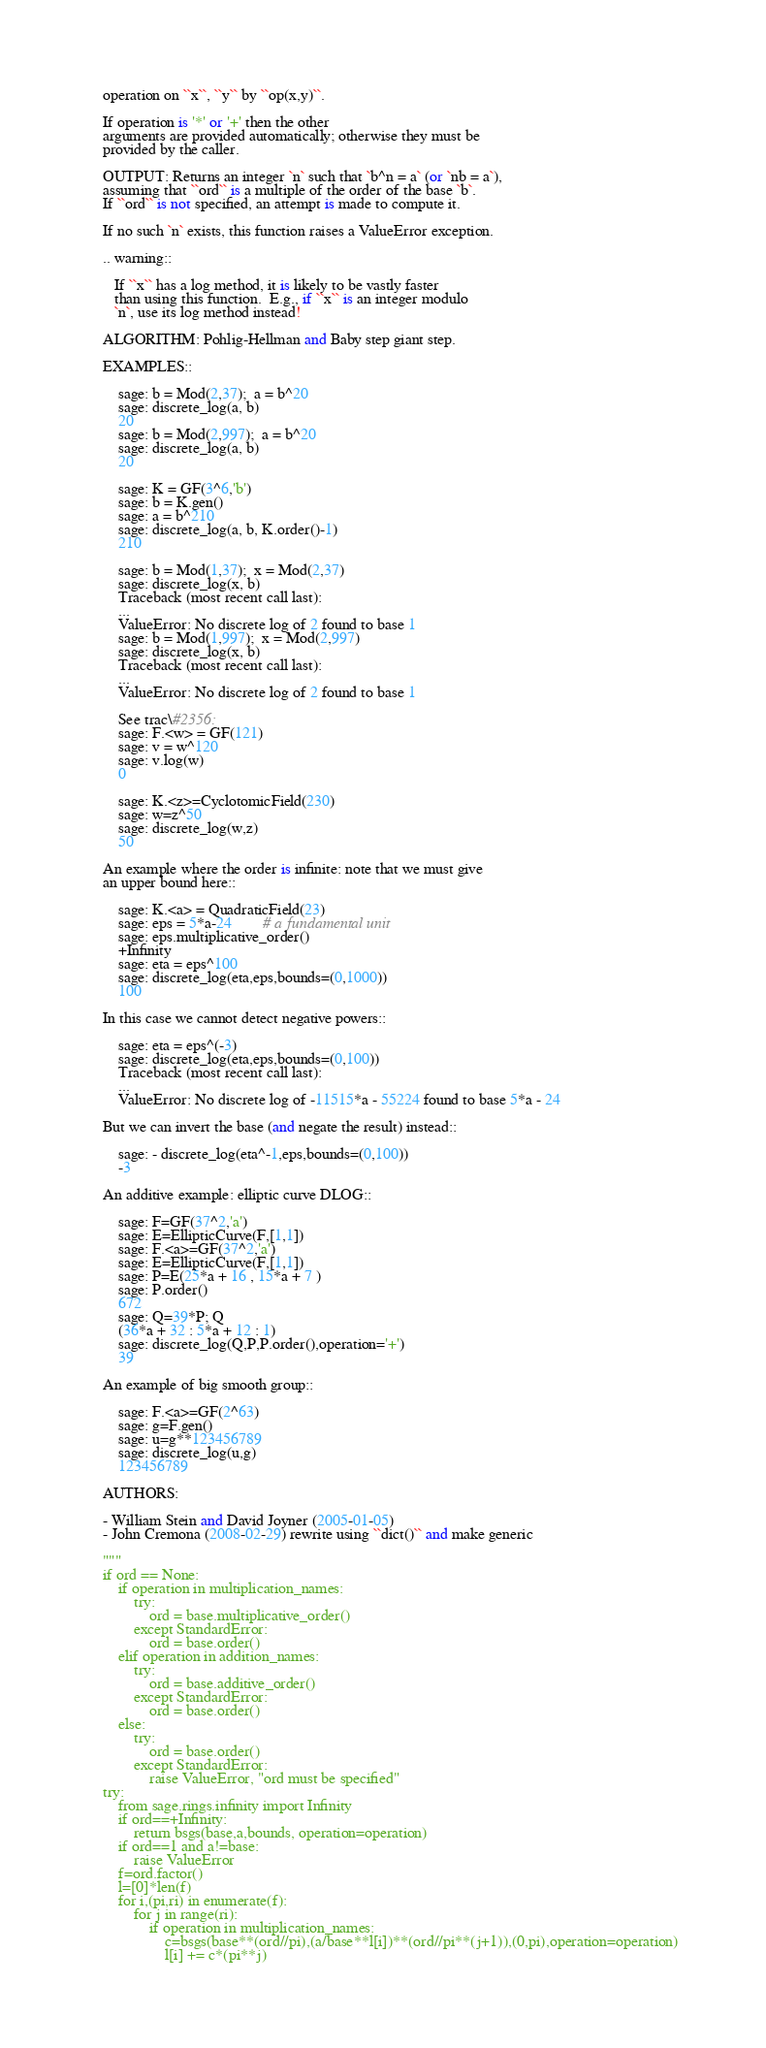Convert code to text. <code><loc_0><loc_0><loc_500><loc_500><_Python_>    operation on ``x``, ``y`` by ``op(x,y)``.

    If operation is '*' or '+' then the other
    arguments are provided automatically; otherwise they must be
    provided by the caller.

    OUTPUT: Returns an integer `n` such that `b^n = a` (or `nb = a`),
    assuming that ``ord`` is a multiple of the order of the base `b`.
    If ``ord`` is not specified, an attempt is made to compute it.

    If no such `n` exists, this function raises a ValueError exception.

    .. warning::

       If ``x`` has a log method, it is likely to be vastly faster
       than using this function.  E.g., if ``x`` is an integer modulo
       `n`, use its log method instead!

    ALGORITHM: Pohlig-Hellman and Baby step giant step.

    EXAMPLES::

        sage: b = Mod(2,37);  a = b^20
        sage: discrete_log(a, b)
        20
        sage: b = Mod(2,997);  a = b^20
        sage: discrete_log(a, b)
        20

        sage: K = GF(3^6,'b')
        sage: b = K.gen()
        sage: a = b^210
        sage: discrete_log(a, b, K.order()-1)
        210

        sage: b = Mod(1,37);  x = Mod(2,37)
        sage: discrete_log(x, b)
        Traceback (most recent call last):
        ...
        ValueError: No discrete log of 2 found to base 1
        sage: b = Mod(1,997);  x = Mod(2,997)
        sage: discrete_log(x, b)
        Traceback (most recent call last):
        ...
        ValueError: No discrete log of 2 found to base 1

        See trac\#2356:
        sage: F.<w> = GF(121)
        sage: v = w^120
        sage: v.log(w)
        0

        sage: K.<z>=CyclotomicField(230)
        sage: w=z^50
        sage: discrete_log(w,z)
        50

    An example where the order is infinite: note that we must give
    an upper bound here::

        sage: K.<a> = QuadraticField(23)
        sage: eps = 5*a-24        # a fundamental unit
        sage: eps.multiplicative_order()
        +Infinity
        sage: eta = eps^100
        sage: discrete_log(eta,eps,bounds=(0,1000))
        100

    In this case we cannot detect negative powers::

        sage: eta = eps^(-3)
        sage: discrete_log(eta,eps,bounds=(0,100))
        Traceback (most recent call last):
        ...
        ValueError: No discrete log of -11515*a - 55224 found to base 5*a - 24

    But we can invert the base (and negate the result) instead::

        sage: - discrete_log(eta^-1,eps,bounds=(0,100))
        -3

    An additive example: elliptic curve DLOG::

        sage: F=GF(37^2,'a')
        sage: E=EllipticCurve(F,[1,1])
        sage: F.<a>=GF(37^2,'a')
        sage: E=EllipticCurve(F,[1,1])
        sage: P=E(25*a + 16 , 15*a + 7 )
        sage: P.order()
        672
        sage: Q=39*P; Q
        (36*a + 32 : 5*a + 12 : 1)
        sage: discrete_log(Q,P,P.order(),operation='+')
        39

    An example of big smooth group::

        sage: F.<a>=GF(2^63)
        sage: g=F.gen()
        sage: u=g**123456789
        sage: discrete_log(u,g)
        123456789

    AUTHORS:

    - William Stein and David Joyner (2005-01-05)
    - John Cremona (2008-02-29) rewrite using ``dict()`` and make generic

    """
    if ord == None:
        if operation in multiplication_names:
            try:
                ord = base.multiplicative_order()
            except StandardError:
                ord = base.order()
        elif operation in addition_names:
            try:
                ord = base.additive_order()
            except StandardError:
                ord = base.order()
        else:
            try:
                ord = base.order()
            except StandardError:
                raise ValueError, "ord must be specified"
    try:
        from sage.rings.infinity import Infinity
        if ord==+Infinity:
            return bsgs(base,a,bounds, operation=operation)
        if ord==1 and a!=base:
            raise ValueError
        f=ord.factor()
        l=[0]*len(f)
        for i,(pi,ri) in enumerate(f):
            for j in range(ri):
                if operation in multiplication_names:
                    c=bsgs(base**(ord//pi),(a/base**l[i])**(ord//pi**(j+1)),(0,pi),operation=operation)
                    l[i] += c*(pi**j)</code> 